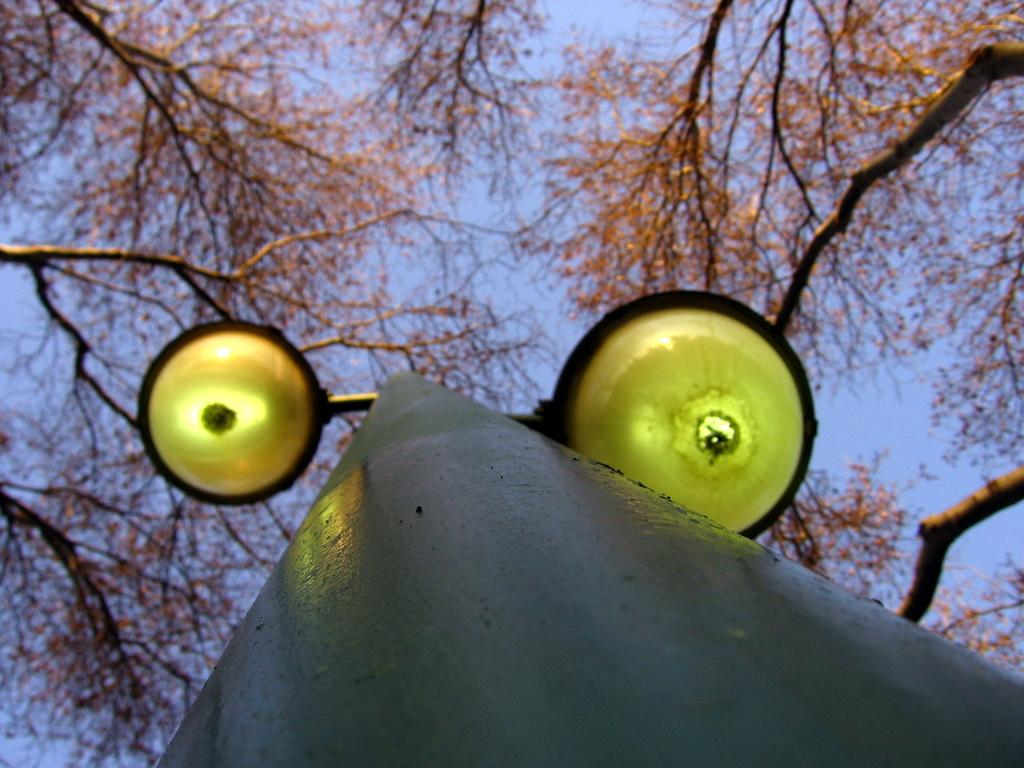What is on the pole in the image? There are lights on a pole in the image. What type of vegetation can be seen in the image? There are trees visible in the image. What is visible in the background of the image? The sky is visible in the image. How many giraffes can be seen in the image? There are no giraffes present in the image. What level of difficulty is the bear climbing in the image? There are no bears present in the image, and therefore no climbing activity can be observed. 